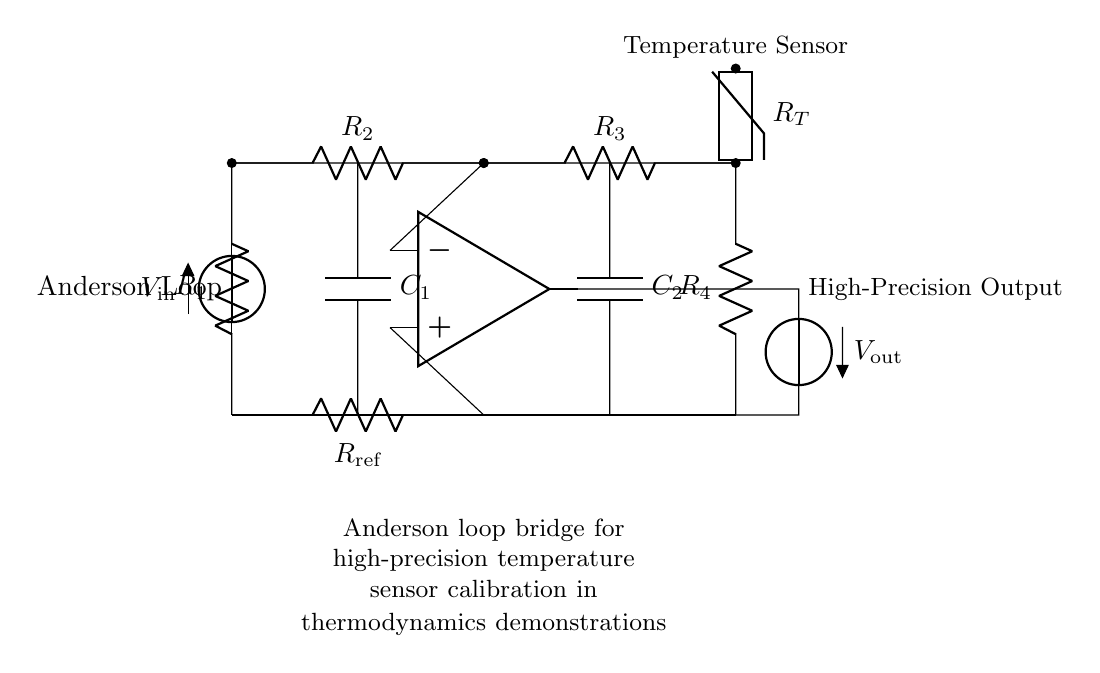What is the type of temperature sensor used in the circuit? The circuit uses a thermistor as indicated by the labeled component, which is designed for temperature sensing.
Answer: thermistor How many resistors are there in the circuit? The circuit diagram shows a total of four resistors labeled R1, R2, R3, and R4. Therefore, the total number of resistors is four.
Answer: four What does the voltage source provide? The voltage source provides the input voltage denoted as V_in, which is essential for the functioning of the bridge circuit.
Answer: V_in Which components are connected in parallel in the circuit? The resistors R2 and R3 are connected in parallel, while the capacitors C1 and C2 are also connected in parallel to their respective branches.
Answer: R2, R3; C1, C2 What is the purpose of the op-amp in the circuit? The operational amplifier (op-amp) amplifies the voltage difference across its input terminals, which is critical for achieving high-precision output from the temperature calibration process.
Answer: amplification What is the significance of the reference resistor? The reference resistor R_ref is crucial for setting a baseline resistance value, enabling accurate calibration of the thermistor readings by balancing the bridge circuit.
Answer: calibration What is the output voltage referred to in the circuit? The output voltage V_out is the voltage measured across the operational amplifier's output, and it reflects the amplified difference corresponding to the calibration of the sensor.
Answer: V_out 